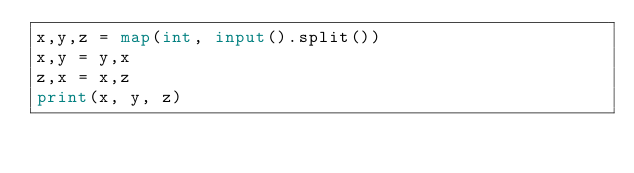Convert code to text. <code><loc_0><loc_0><loc_500><loc_500><_Python_>x,y,z = map(int, input().split())
x,y = y,x
z,x = x,z
print(x, y, z)</code> 